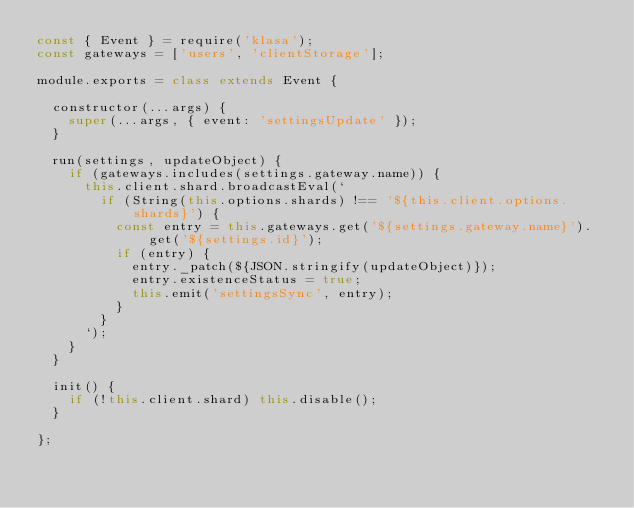<code> <loc_0><loc_0><loc_500><loc_500><_JavaScript_>const { Event } = require('klasa');
const gateways = ['users', 'clientStorage'];

module.exports = class extends Event {

	constructor(...args) {
		super(...args, { event: 'settingsUpdate' });
	}

	run(settings, updateObject) {
		if (gateways.includes(settings.gateway.name)) {
			this.client.shard.broadcastEval(`
				if (String(this.options.shards) !== '${this.client.options.shards}') {
					const entry = this.gateways.get('${settings.gateway.name}').get('${settings.id}');
					if (entry) {
						entry._patch(${JSON.stringify(updateObject)});
						entry.existenceStatus = true;
						this.emit('settingsSync', entry);
					}
				}
			`);
		}
	}

	init() {
		if (!this.client.shard) this.disable();
	}

};
</code> 